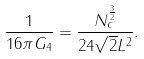<formula> <loc_0><loc_0><loc_500><loc_500>\frac { 1 } { 1 6 \pi G _ { 4 } } = \frac { N _ { c } ^ { \frac { 3 } { 2 } } } { 2 4 \sqrt { 2 } L ^ { 2 } } .</formula> 